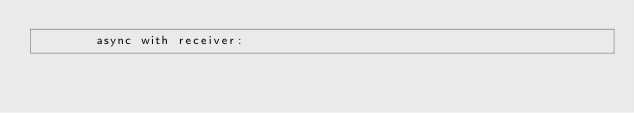Convert code to text. <code><loc_0><loc_0><loc_500><loc_500><_Python_>        async with receiver:</code> 